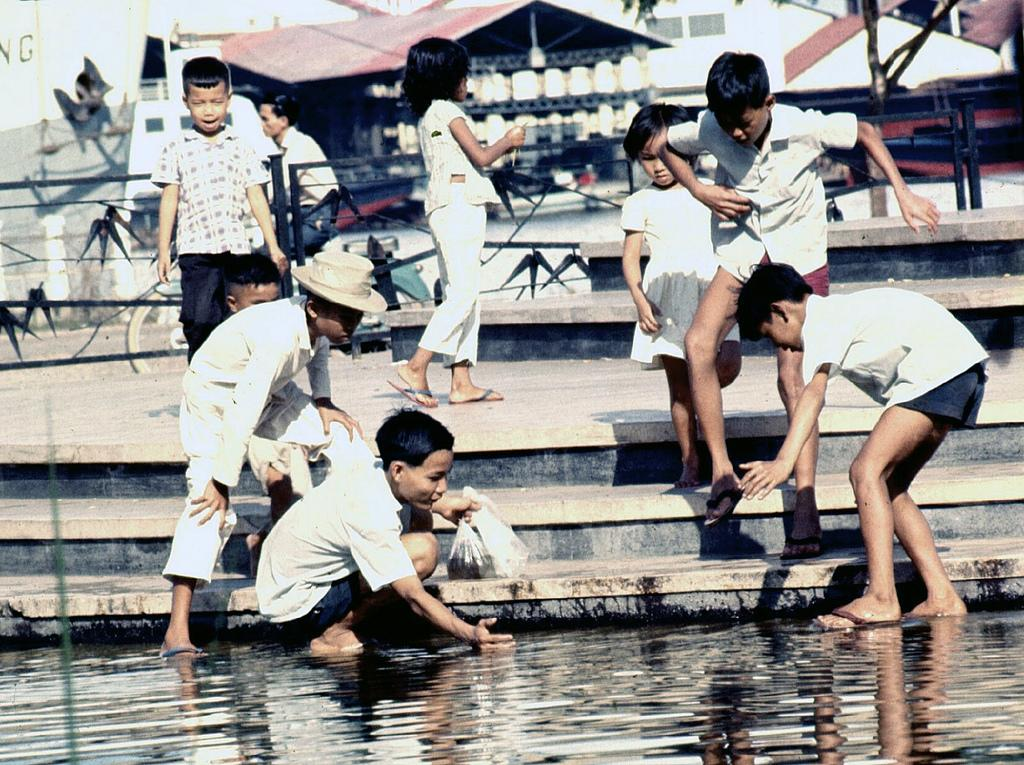Who is present in the image? There are children in the image. What can be seen in the image besides the children? There is water visible in the image. What is visible in the background of the image? There are buildings in the background of the image. What type of underwear are the children wearing in the image? There is no information about the children's underwear in the image, so it cannot be determined. 